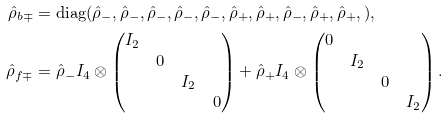<formula> <loc_0><loc_0><loc_500><loc_500>\hat { \rho } _ { b \mp } & = \text {diag} ( \hat { \rho } _ { - } , \hat { \rho } _ { - } , \hat { \rho } _ { - } , \hat { \rho } _ { - } , \hat { \rho } _ { - } , \hat { \rho } _ { + } , \hat { \rho } _ { + } , \hat { \rho } _ { - } , \hat { \rho } _ { + } , \hat { \rho } _ { + } , ) , \\ \hat { \rho } _ { f \mp } & = \hat { \rho } _ { - } I _ { 4 } \otimes \begin{pmatrix} I _ { 2 } & & & \\ & 0 & & \\ & & I _ { 2 } & \\ & & & 0 \end{pmatrix} + \hat { \rho } _ { + } I _ { 4 } \otimes \begin{pmatrix} 0 & & & \\ & I _ { 2 } & & \\ & & 0 & \\ & & & I _ { 2 } \end{pmatrix} .</formula> 